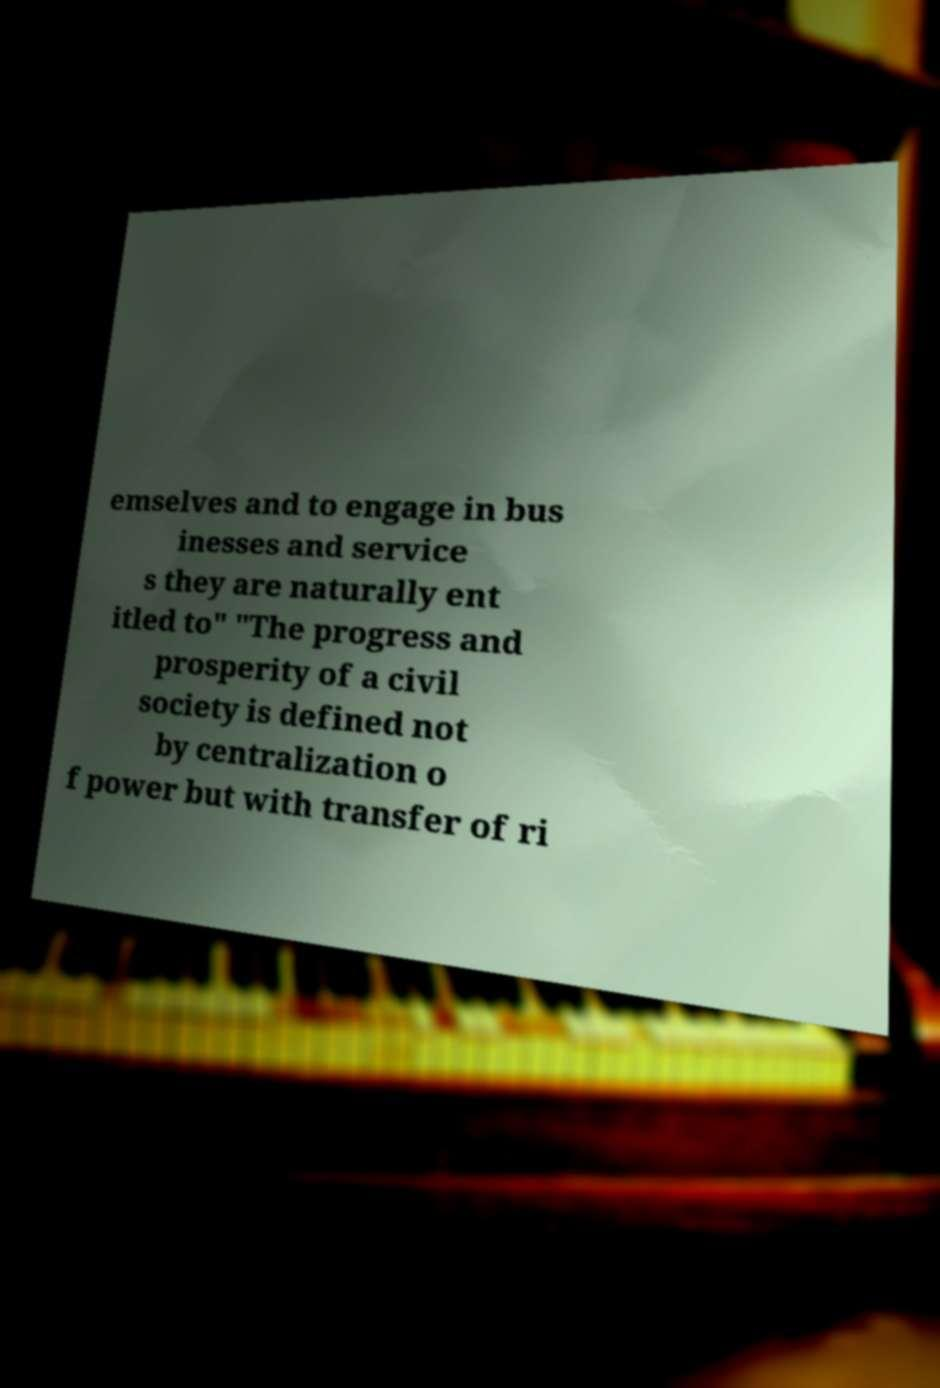Could you extract and type out the text from this image? emselves and to engage in bus inesses and service s they are naturally ent itled to" "The progress and prosperity of a civil society is defined not by centralization o f power but with transfer of ri 